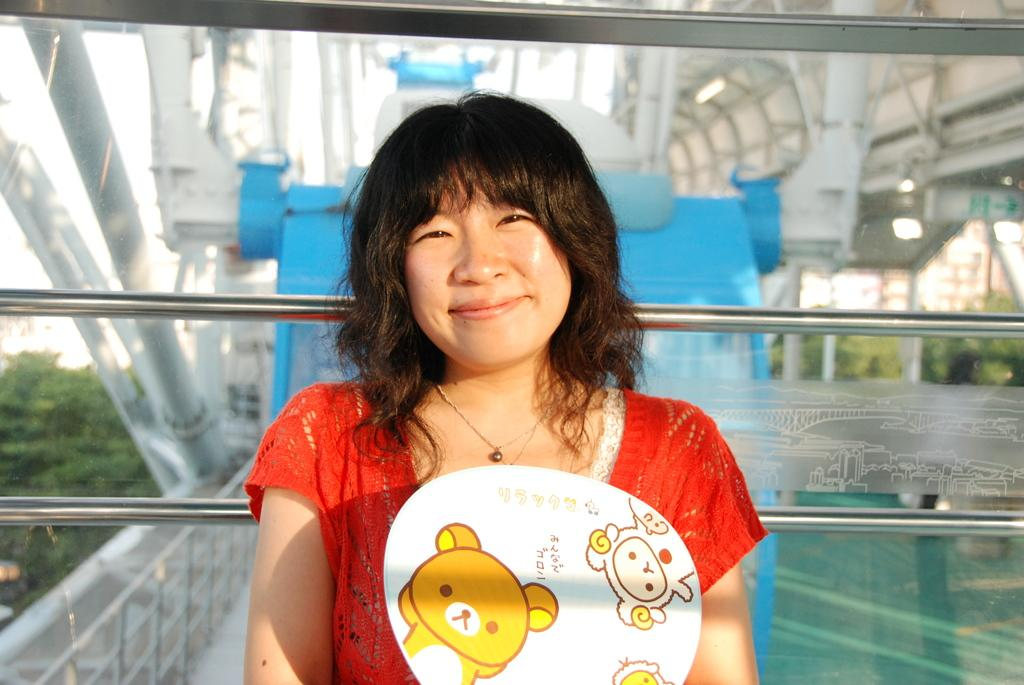Who is present in the image? There is a woman in the image. What is the woman's facial expression? The woman is smiling. What can be seen through the glass object in the image? Poles, a bridge, a board, and trees can be seen through the glass. What type of apparel is the woman wearing to wash the gate in the image? There is no gate or washing activity present in the image. The woman is simply smiling, and no apparel is mentioned in the provided facts. 